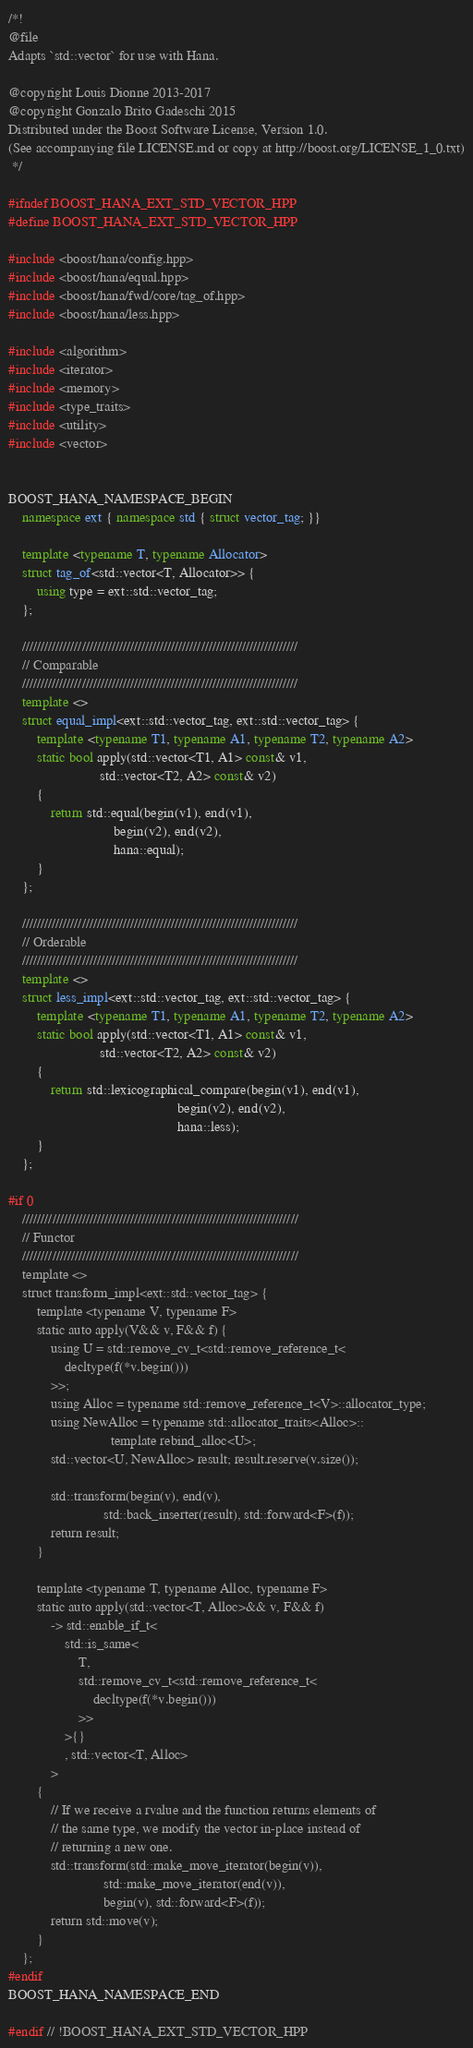<code> <loc_0><loc_0><loc_500><loc_500><_C++_>/*!
@file
Adapts `std::vector` for use with Hana.

@copyright Louis Dionne 2013-2017
@copyright Gonzalo Brito Gadeschi 2015
Distributed under the Boost Software License, Version 1.0.
(See accompanying file LICENSE.md or copy at http://boost.org/LICENSE_1_0.txt)
 */

#ifndef BOOST_HANA_EXT_STD_VECTOR_HPP
#define BOOST_HANA_EXT_STD_VECTOR_HPP

#include <boost/hana/config.hpp>
#include <boost/hana/equal.hpp>
#include <boost/hana/fwd/core/tag_of.hpp>
#include <boost/hana/less.hpp>

#include <algorithm>
#include <iterator>
#include <memory>
#include <type_traits>
#include <utility>
#include <vector>


BOOST_HANA_NAMESPACE_BEGIN
    namespace ext { namespace std { struct vector_tag; }}

    template <typename T, typename Allocator>
    struct tag_of<std::vector<T, Allocator>> {
        using type = ext::std::vector_tag;
    };

    //////////////////////////////////////////////////////////////////////////
    // Comparable
    //////////////////////////////////////////////////////////////////////////
    template <>
    struct equal_impl<ext::std::vector_tag, ext::std::vector_tag> {
        template <typename T1, typename A1, typename T2, typename A2>
        static bool apply(std::vector<T1, A1> const& v1,
                          std::vector<T2, A2> const& v2)
        {
            return std::equal(begin(v1), end(v1),
                              begin(v2), end(v2),
                              hana::equal);
        }
    };

    //////////////////////////////////////////////////////////////////////////
    // Orderable
    //////////////////////////////////////////////////////////////////////////
    template <>
    struct less_impl<ext::std::vector_tag, ext::std::vector_tag> {
        template <typename T1, typename A1, typename T2, typename A2>
        static bool apply(std::vector<T1, A1> const& v1,
                          std::vector<T2, A2> const& v2)
        {
            return std::lexicographical_compare(begin(v1), end(v1),
                                                begin(v2), end(v2),
                                                hana::less);
        }
    };

#if 0
    //////////////////////////////////////////////////////////////////////////
    // Functor
    //////////////////////////////////////////////////////////////////////////
    template <>
    struct transform_impl<ext::std::vector_tag> {
        template <typename V, typename F>
        static auto apply(V&& v, F&& f) {
            using U = std::remove_cv_t<std::remove_reference_t<
                decltype(f(*v.begin()))
            >>;
            using Alloc = typename std::remove_reference_t<V>::allocator_type;
            using NewAlloc = typename std::allocator_traits<Alloc>::
                             template rebind_alloc<U>;
            std::vector<U, NewAlloc> result; result.reserve(v.size());

            std::transform(begin(v), end(v),
                           std::back_inserter(result), std::forward<F>(f));
            return result;
        }

        template <typename T, typename Alloc, typename F>
        static auto apply(std::vector<T, Alloc>&& v, F&& f)
            -> std::enable_if_t<
                std::is_same<
                    T,
                    std::remove_cv_t<std::remove_reference_t<
                        decltype(f(*v.begin()))
                    >>
                >{}
                , std::vector<T, Alloc>
            >
        {
            // If we receive a rvalue and the function returns elements of
            // the same type, we modify the vector in-place instead of
            // returning a new one.
            std::transform(std::make_move_iterator(begin(v)),
                           std::make_move_iterator(end(v)),
                           begin(v), std::forward<F>(f));
            return std::move(v);
        }
    };
#endif
BOOST_HANA_NAMESPACE_END

#endif // !BOOST_HANA_EXT_STD_VECTOR_HPP
</code> 